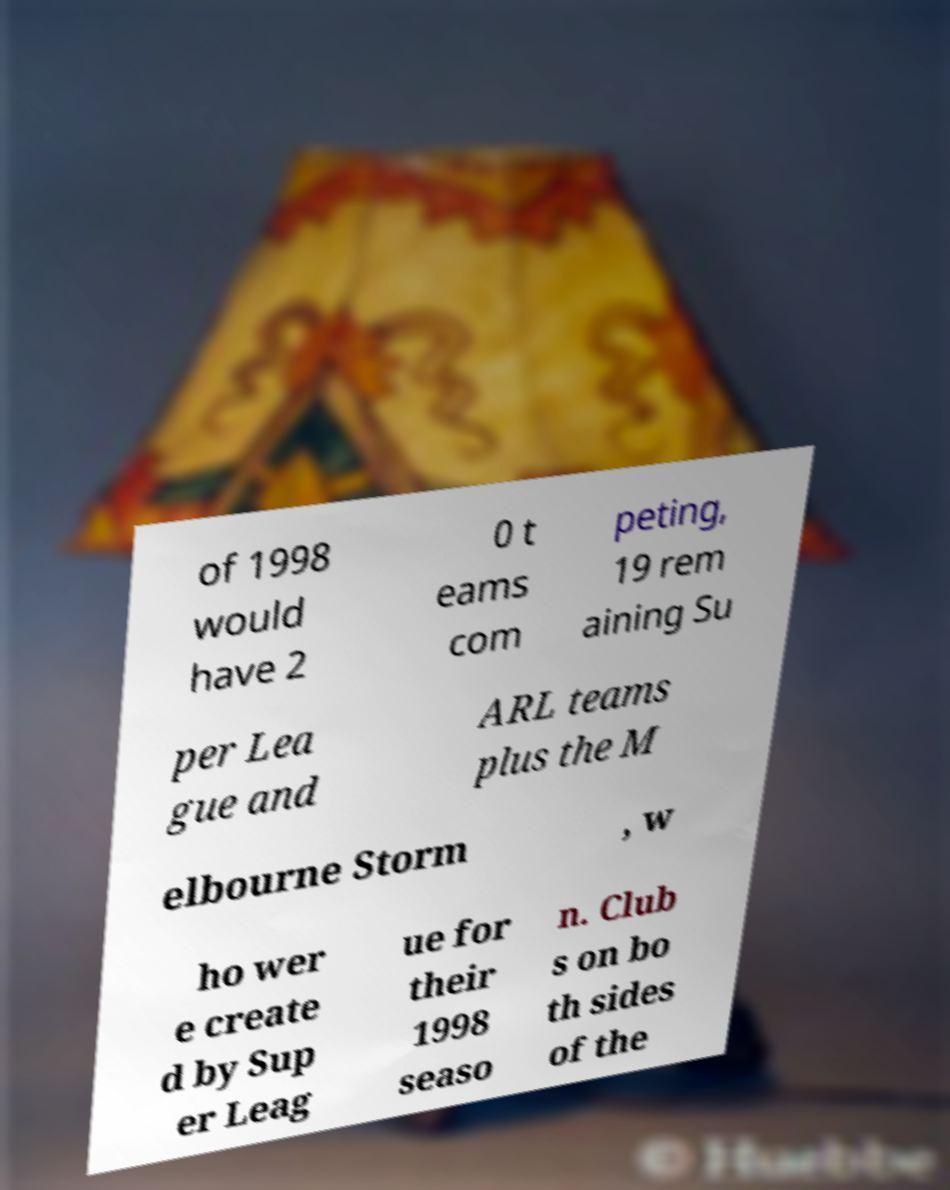What messages or text are displayed in this image? I need them in a readable, typed format. of 1998 would have 2 0 t eams com peting, 19 rem aining Su per Lea gue and ARL teams plus the M elbourne Storm , w ho wer e create d by Sup er Leag ue for their 1998 seaso n. Club s on bo th sides of the 